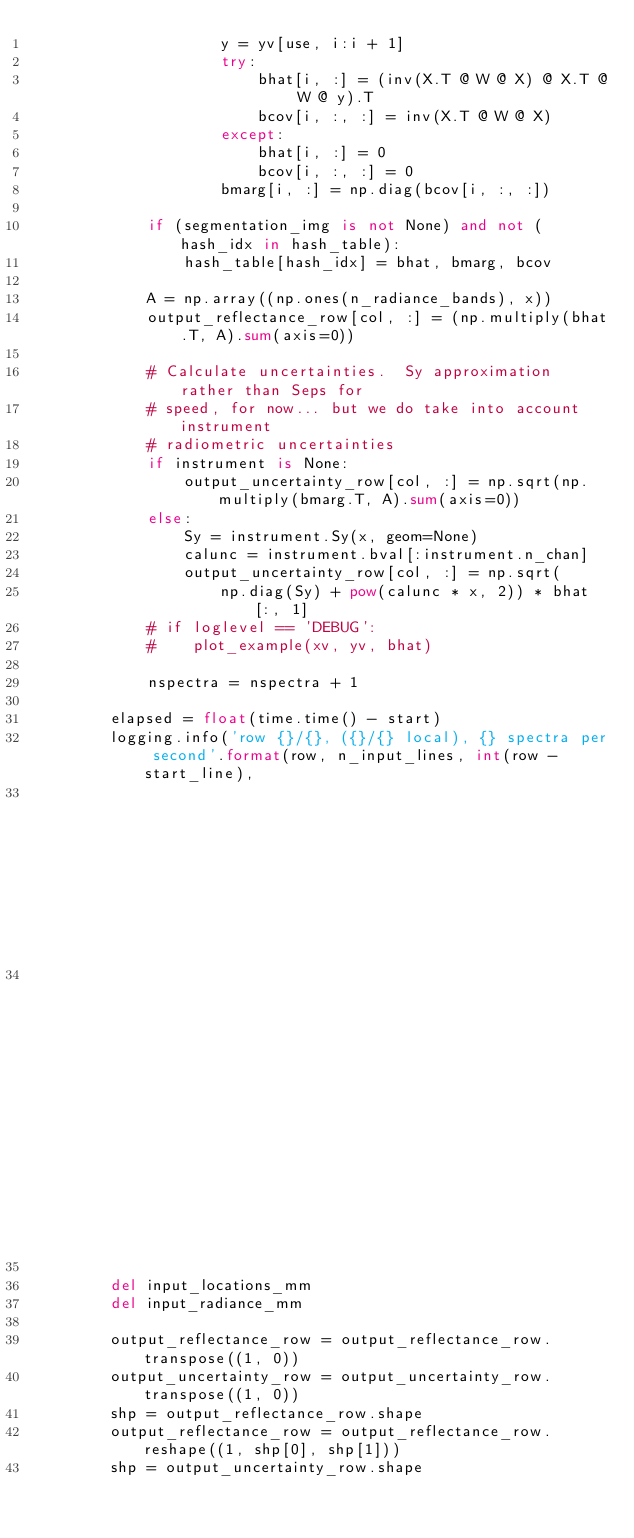<code> <loc_0><loc_0><loc_500><loc_500><_Python_>                    y = yv[use, i:i + 1]
                    try:
                        bhat[i, :] = (inv(X.T @ W @ X) @ X.T @ W @ y).T
                        bcov[i, :, :] = inv(X.T @ W @ X)
                    except:
                        bhat[i, :] = 0
                        bcov[i, :, :] = 0
                    bmarg[i, :] = np.diag(bcov[i, :, :])

            if (segmentation_img is not None) and not (hash_idx in hash_table):
                hash_table[hash_idx] = bhat, bmarg, bcov

            A = np.array((np.ones(n_radiance_bands), x))
            output_reflectance_row[col, :] = (np.multiply(bhat.T, A).sum(axis=0))

            # Calculate uncertainties.  Sy approximation rather than Seps for
            # speed, for now... but we do take into account instrument
            # radiometric uncertainties
            if instrument is None:
                output_uncertainty_row[col, :] = np.sqrt(np.multiply(bmarg.T, A).sum(axis=0))
            else:
                Sy = instrument.Sy(x, geom=None)
                calunc = instrument.bval[:instrument.n_chan]
                output_uncertainty_row[col, :] = np.sqrt(
                    np.diag(Sy) + pow(calunc * x, 2)) * bhat[:, 1]
            # if loglevel == 'DEBUG':
            #    plot_example(xv, yv, bhat)

            nspectra = nspectra + 1

        elapsed = float(time.time() - start)
        logging.info('row {}/{}, ({}/{} local), {} spectra per second'.format(row, n_input_lines, int(row - start_line),
                                                                              int(stop_line - start_line),
                                                                              round(float(nspectra) / elapsed, 2)))

        del input_locations_mm
        del input_radiance_mm

        output_reflectance_row = output_reflectance_row.transpose((1, 0))
        output_uncertainty_row = output_uncertainty_row.transpose((1, 0))
        shp = output_reflectance_row.shape
        output_reflectance_row = output_reflectance_row.reshape((1, shp[0], shp[1]))
        shp = output_uncertainty_row.shape</code> 